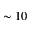Convert formula to latex. <formula><loc_0><loc_0><loc_500><loc_500>\sim 1 0</formula> 